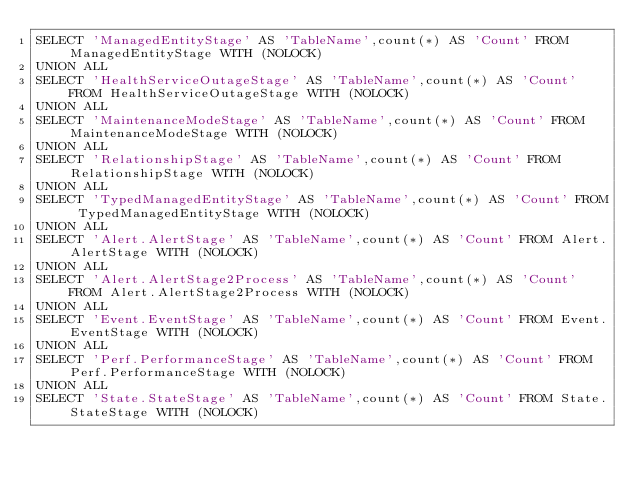Convert code to text. <code><loc_0><loc_0><loc_500><loc_500><_SQL_>SELECT 'ManagedEntityStage' AS 'TableName',count(*) AS 'Count' FROM ManagedEntityStage WITH (NOLOCK)
UNION ALL
SELECT 'HealthServiceOutageStage' AS 'TableName',count(*) AS 'Count' FROM HealthServiceOutageStage WITH (NOLOCK)
UNION ALL
SELECT 'MaintenanceModeStage' AS 'TableName',count(*) AS 'Count' FROM MaintenanceModeStage WITH (NOLOCK)
UNION ALL
SELECT 'RelationshipStage' AS 'TableName',count(*) AS 'Count' FROM RelationshipStage WITH (NOLOCK)
UNION ALL
SELECT 'TypedManagedEntityStage' AS 'TableName',count(*) AS 'Count' FROM TypedManagedEntityStage WITH (NOLOCK)
UNION ALL
SELECT 'Alert.AlertStage' AS 'TableName',count(*) AS 'Count' FROM Alert.AlertStage WITH (NOLOCK)
UNION ALL
SELECT 'Alert.AlertStage2Process' AS 'TableName',count(*) AS 'Count' FROM Alert.AlertStage2Process WITH (NOLOCK)
UNION ALL
SELECT 'Event.EventStage' AS 'TableName',count(*) AS 'Count' FROM Event.EventStage WITH (NOLOCK)
UNION ALL
SELECT 'Perf.PerformanceStage' AS 'TableName',count(*) AS 'Count' FROM Perf.PerformanceStage WITH (NOLOCK)
UNION ALL
SELECT 'State.StateStage' AS 'TableName',count(*) AS 'Count' FROM State.StateStage WITH (NOLOCK)</code> 